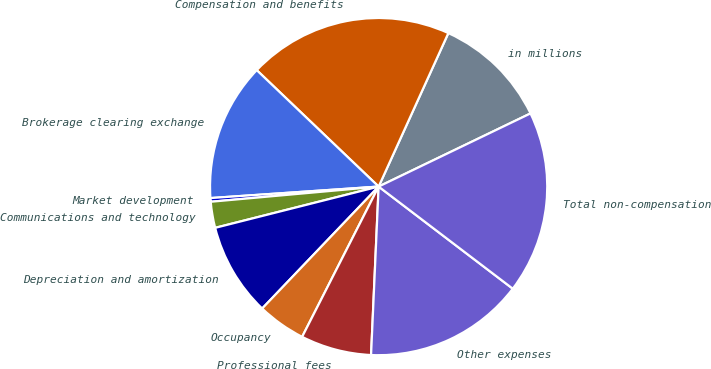Convert chart to OTSL. <chart><loc_0><loc_0><loc_500><loc_500><pie_chart><fcel>in millions<fcel>Compensation and benefits<fcel>Brokerage clearing exchange<fcel>Market development<fcel>Communications and technology<fcel>Depreciation and amortization<fcel>Occupancy<fcel>Professional fees<fcel>Other expenses<fcel>Total non-compensation<nl><fcel>11.07%<fcel>19.65%<fcel>13.22%<fcel>0.35%<fcel>2.5%<fcel>8.93%<fcel>4.64%<fcel>6.78%<fcel>15.36%<fcel>17.5%<nl></chart> 